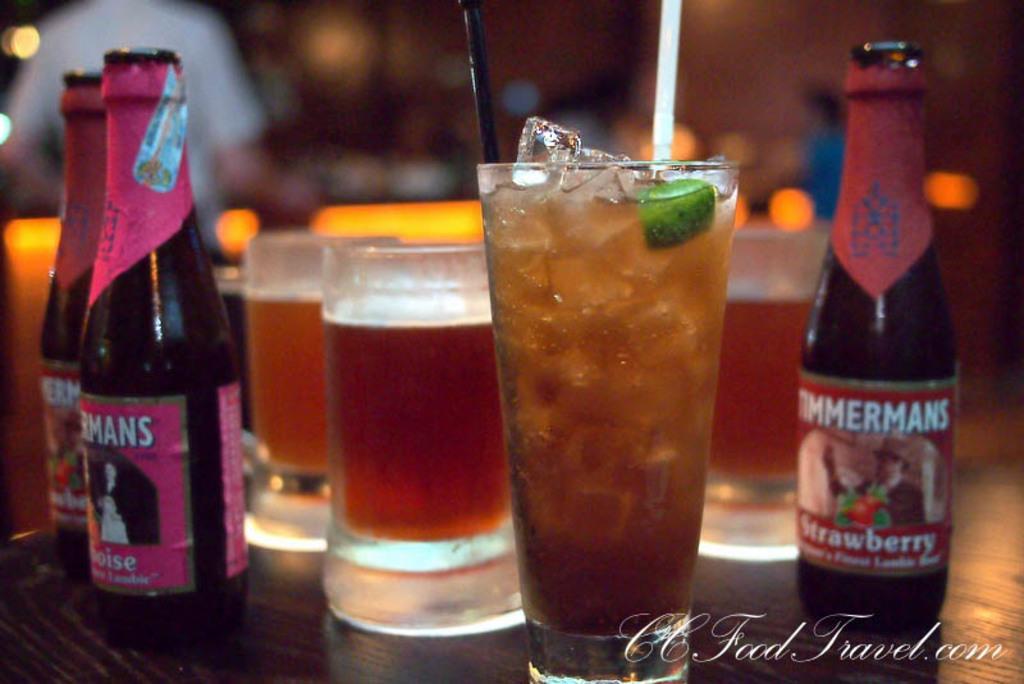Could you give a brief overview of what you see in this image? In the picture we can see some bottles, glasses in which there is some drink. 